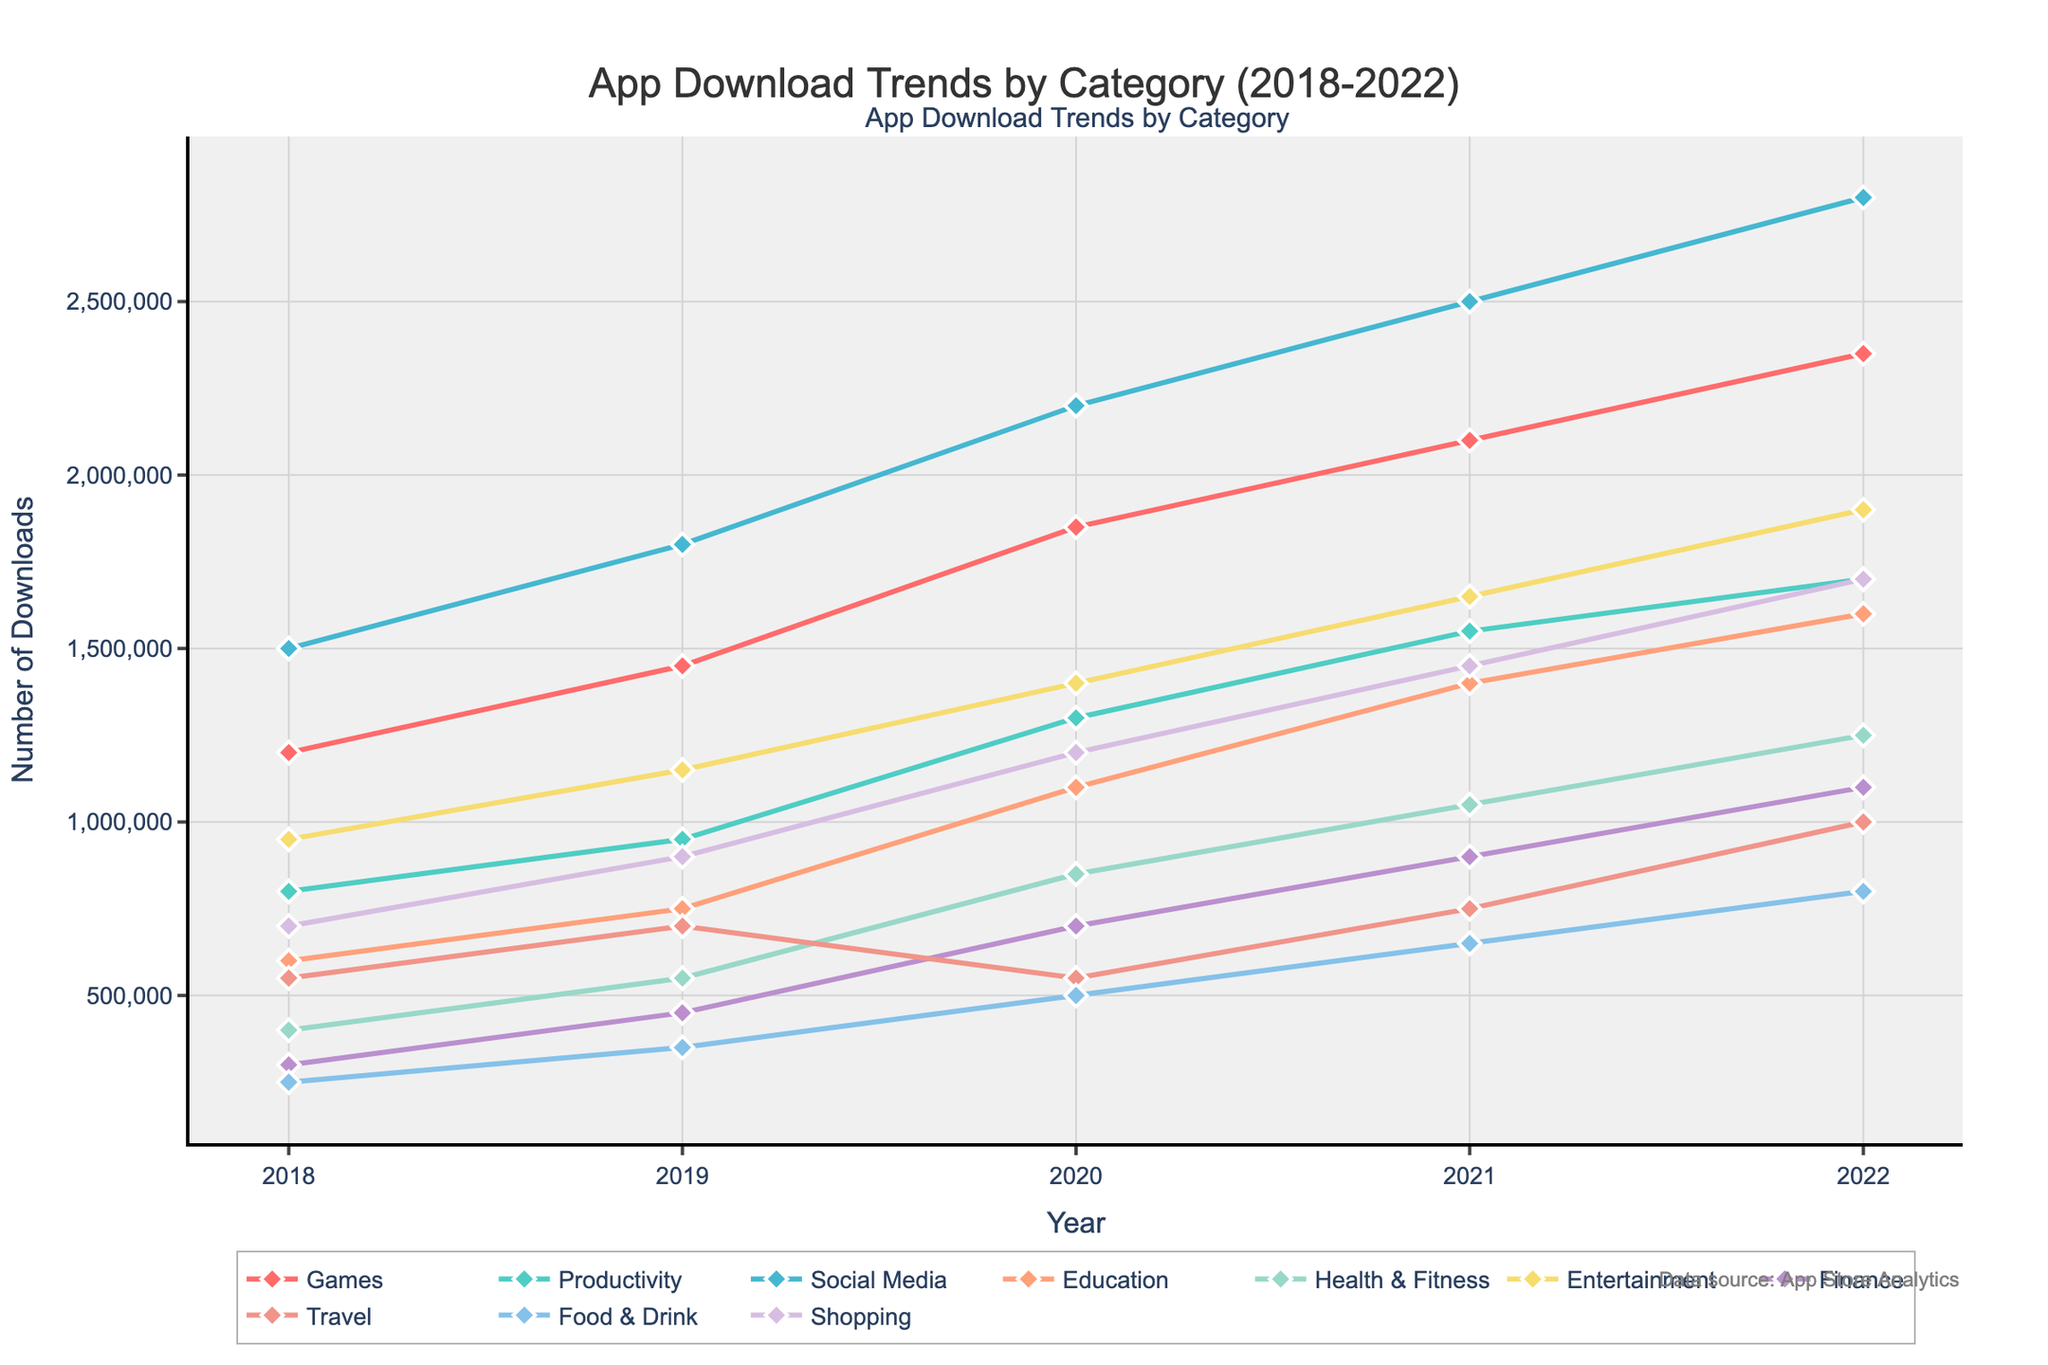Which category had the highest number of downloads in 2022? Look at the last data point for each category in the plot. The category with the highest number of downloads in 2022 is the one with the highest position on the y-axis.
Answer: Social Media Which two categories saw the largest increase in downloads from 2018 to 2022? Compute the difference between 2022 and 2018 for each category. The two largest differences represent the biggest increases. Games increased by 1,150,000, Productivity by 900,000, Social Media by 1,300,000 (largest), Education by 1,000,000, Health & Fitness by 850,000, Entertainment by 950,000, Finance by 800,000, Travel by 450,000, Food & Drink by 550,000, and Shopping by 1,000,000 (second largest).
Answer: Social Media and Shopping Which category had a decline in downloads between any two consecutive years? Look for sections in the plot where the line dips downward. This is visible for Travel between 2019 and 2020.
Answer: Travel What was the total number of downloads for Education in 2020 and 2021 combined? Add the downloads for Education in the years 2020 and 2021. For 2020, it was 1,100,000 and for 2021, it was 1,400,000. Their sum is 1,100,000 + 1,400,000 = 2,500,000.
Answer: 2,500,000 Which category had the slowest growth rate from 2018 to 2022? Calculate the growth rate for each category by dividing the increase in downloads from 2018 to 2022 by the 2018 downloads. Choose the smallest. Growth rates: Games: 96%, Productivity: 112.5%, Social Media: 86.7%, Education: 166.7%, Health & Fitness: 212.5%, Entertainment: 100%, Finance: 266.7%, Travel: 81.8%, Food & Drink: 220%, Shopping: 142.9%. The smallest growth rate is for Social Media at 86.7%.
Answer: Social Media What is the average number of downloads for the Health & Fitness category from 2018 to 2022? Add the downloads for each year for Health & Fitness and divide by the number of years: (400,000 + 550,000 + 850,000 + 1,050,000 + 1,250,000) / 5. The total is 4,100,000, and the average is 4,100,000 / 5 = 820,000.
Answer: 820,000 In what year did all categories experience an increase in downloads compared to the previous year? Check the lines for each category to see if there is a consistent upward trend for all categories between consecutive years. In every year from 2018 to 2022, all categories except Travel increased in every interval except for 2019 to 2020. Thus, the year when all categories experienced an increase was from 2018 to 2019.
Answer: 2019 